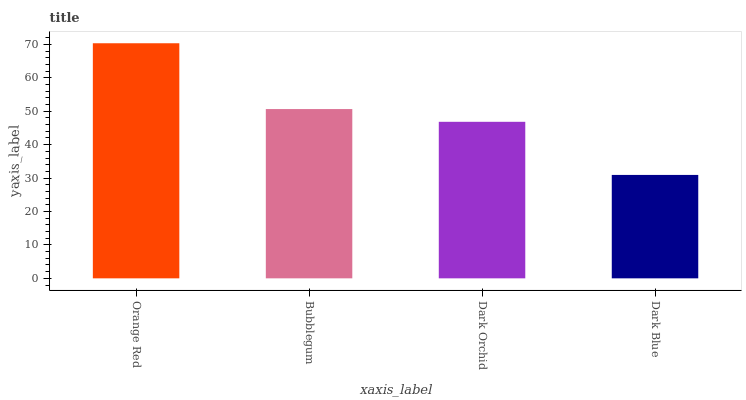Is Bubblegum the minimum?
Answer yes or no. No. Is Bubblegum the maximum?
Answer yes or no. No. Is Orange Red greater than Bubblegum?
Answer yes or no. Yes. Is Bubblegum less than Orange Red?
Answer yes or no. Yes. Is Bubblegum greater than Orange Red?
Answer yes or no. No. Is Orange Red less than Bubblegum?
Answer yes or no. No. Is Bubblegum the high median?
Answer yes or no. Yes. Is Dark Orchid the low median?
Answer yes or no. Yes. Is Dark Orchid the high median?
Answer yes or no. No. Is Dark Blue the low median?
Answer yes or no. No. 